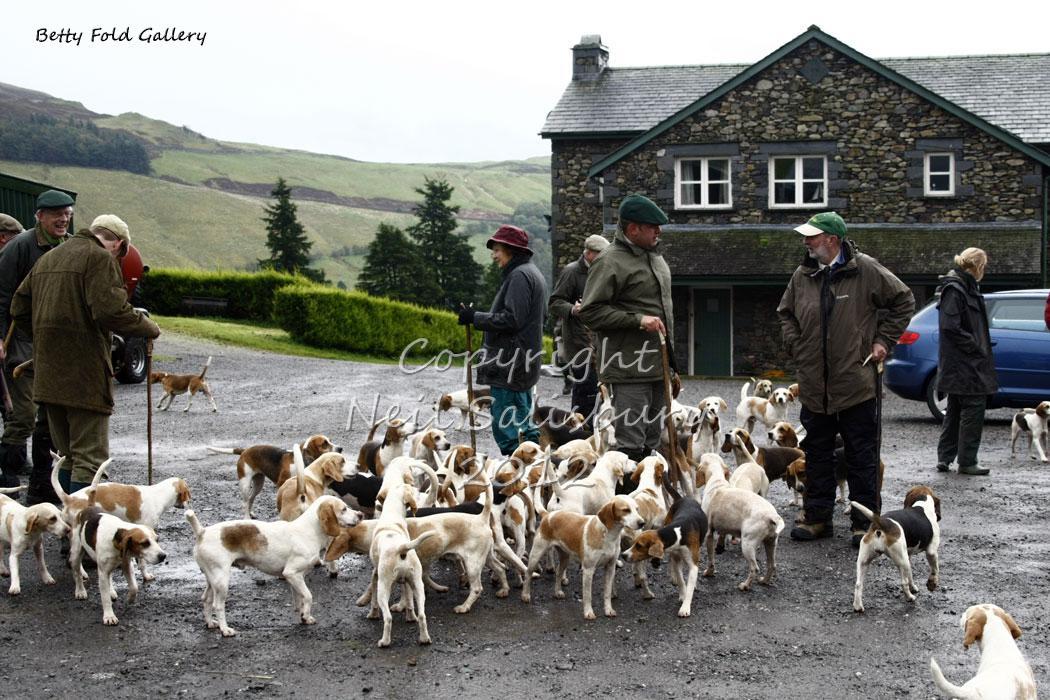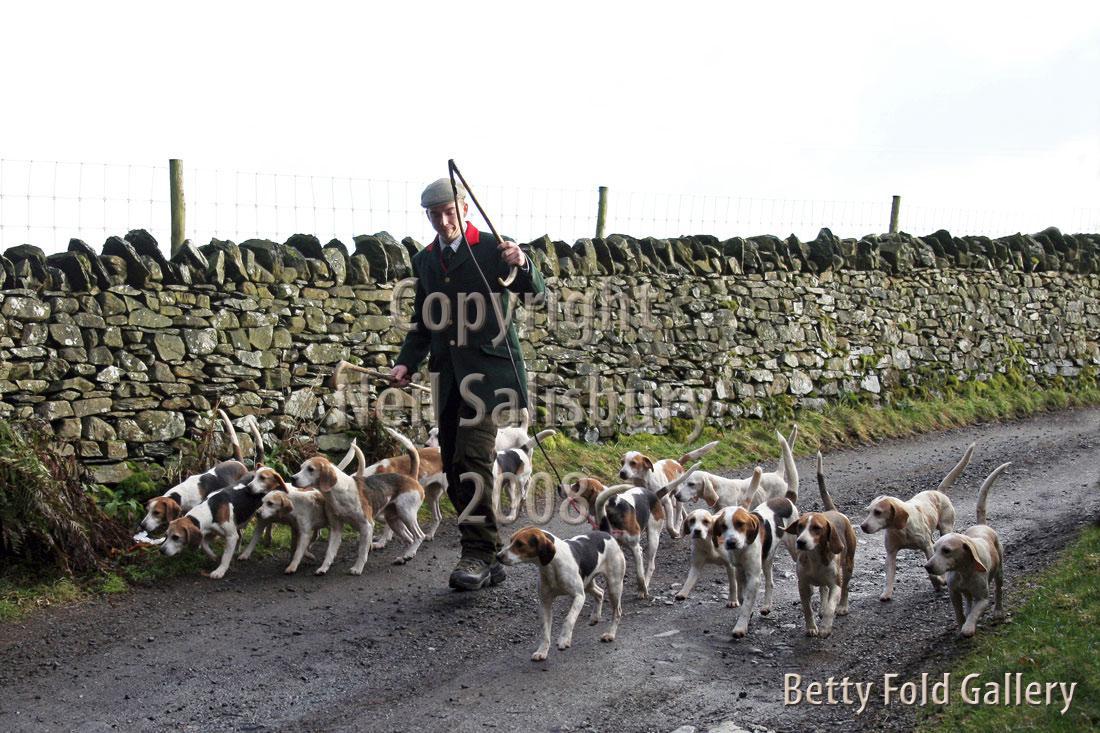The first image is the image on the left, the second image is the image on the right. Examine the images to the left and right. Is the description "there is exactly one person in the image on the left" accurate? Answer yes or no. No. 